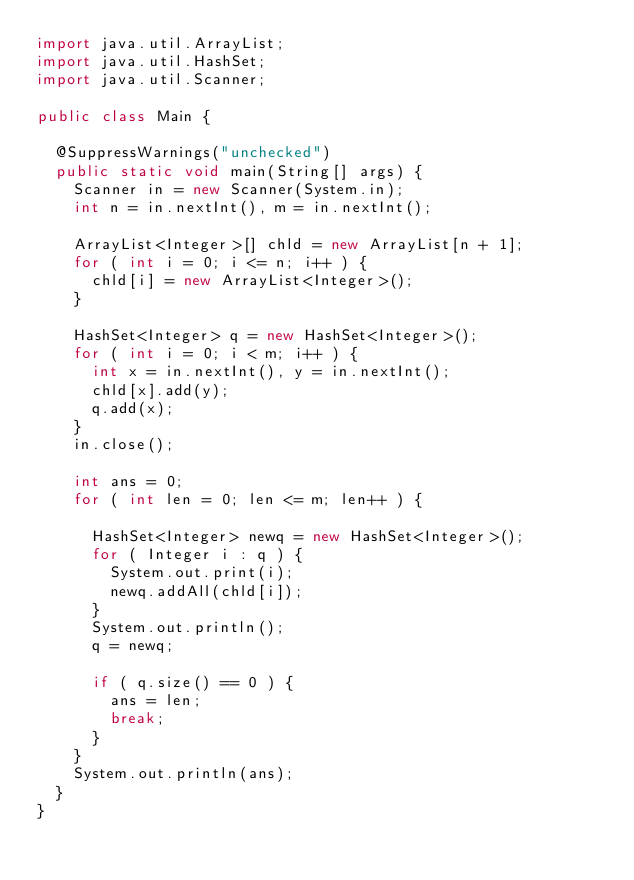Convert code to text. <code><loc_0><loc_0><loc_500><loc_500><_Java_>import java.util.ArrayList;
import java.util.HashSet;
import java.util.Scanner;

public class Main {

	@SuppressWarnings("unchecked")
	public static void main(String[] args) {
		Scanner in = new Scanner(System.in);
		int n = in.nextInt(), m = in.nextInt();

		ArrayList<Integer>[] chld = new ArrayList[n + 1];
		for ( int i = 0; i <= n; i++ ) {
			chld[i] = new ArrayList<Integer>();
		}

		HashSet<Integer> q = new HashSet<Integer>();
		for ( int i = 0; i < m; i++ ) {
			int x = in.nextInt(), y = in.nextInt();
			chld[x].add(y);
			q.add(x);
		}
		in.close();

		int ans = 0;
		for ( int len = 0; len <= m; len++ ) {

			HashSet<Integer> newq = new HashSet<Integer>();
			for ( Integer i : q ) {
				System.out.print(i);
				newq.addAll(chld[i]);
			}
			System.out.println();
			q = newq;

			if ( q.size() == 0 ) {
				ans = len;
				break;
			}
		}
		System.out.println(ans);		
	}
}
</code> 